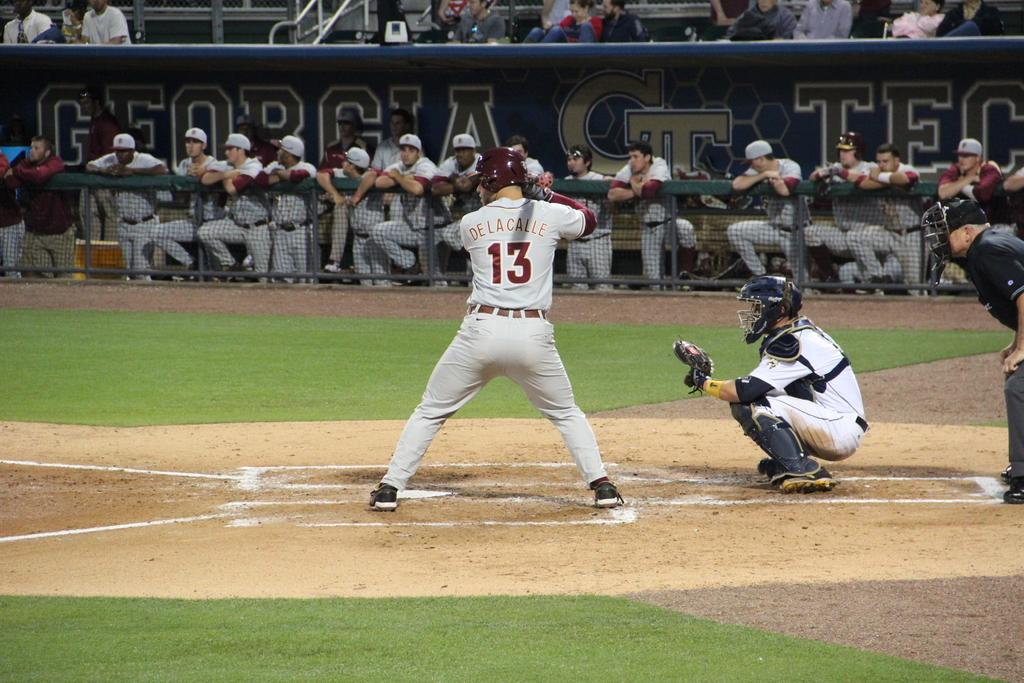<image>
Provide a brief description of the given image. Man in a number 13 jersey getting ready to bat at plate. 